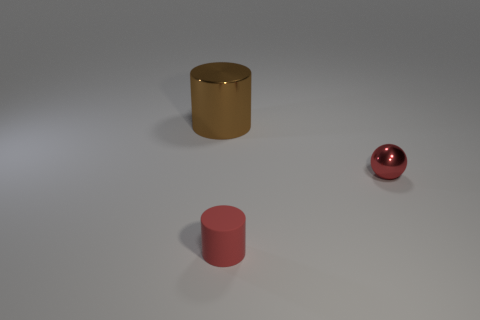There is a tiny object that is behind the small thing that is to the left of the tiny metallic ball; what number of tiny red objects are left of it?
Offer a terse response. 1. Are there any spheres behind the tiny ball?
Offer a terse response. No. What number of other things are the same size as the red shiny object?
Provide a succinct answer. 1. What is the material of the thing that is in front of the large cylinder and on the left side of the tiny shiny object?
Make the answer very short. Rubber. Does the red thing left of the red metallic object have the same shape as the metal thing that is behind the tiny red sphere?
Offer a terse response. Yes. Is there anything else that is made of the same material as the tiny cylinder?
Make the answer very short. No. What shape is the metallic thing right of the red matte cylinder in front of the metallic thing that is in front of the big brown cylinder?
Your response must be concise. Sphere. How many other things are there of the same shape as the large shiny object?
Ensure brevity in your answer.  1. What is the color of the sphere that is the same size as the rubber cylinder?
Ensure brevity in your answer.  Red. How many spheres are either blue matte things or tiny red objects?
Provide a short and direct response. 1. 